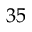<formula> <loc_0><loc_0><loc_500><loc_500>3 5</formula> 